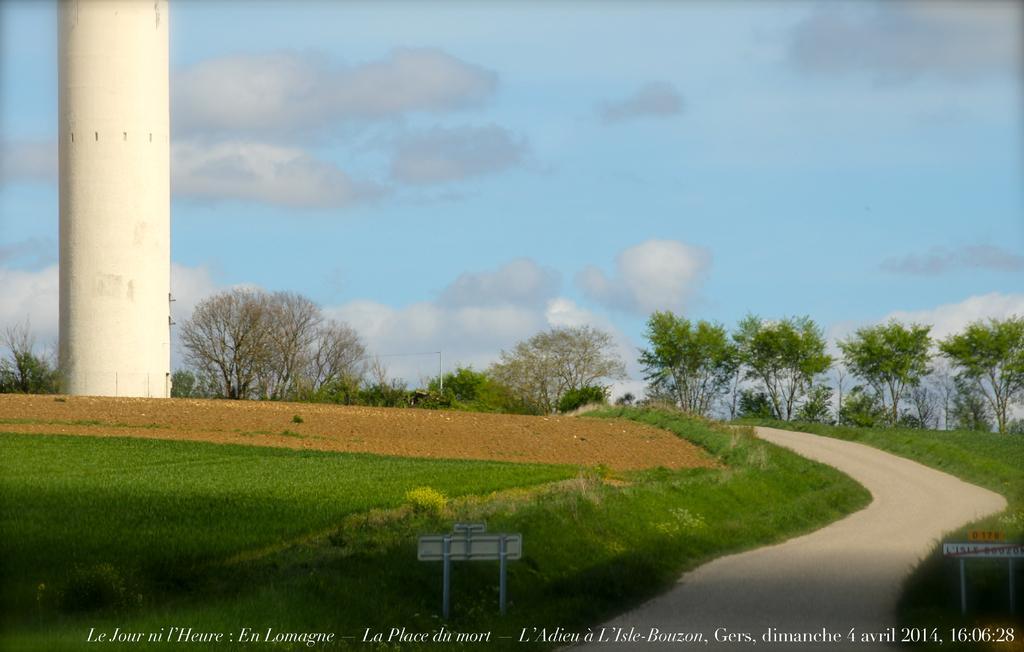Can you describe this image briefly? In this picture I can see trees and grass on the ground and I can see a tower and a path and I can see a small board and a blue cloudy sky and I can see text at the bottom of the picture. 